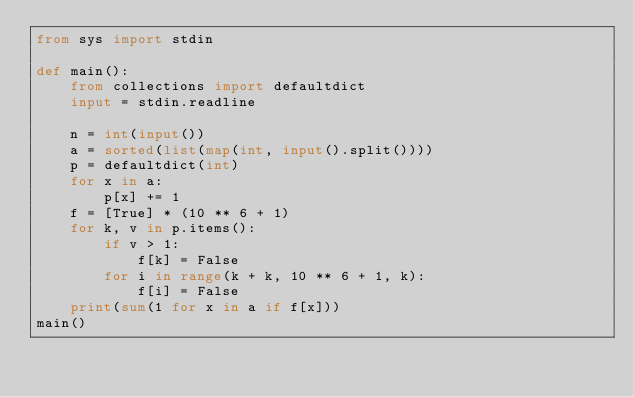Convert code to text. <code><loc_0><loc_0><loc_500><loc_500><_Python_>from sys import stdin

def main():
    from collections import defaultdict
    input = stdin.readline

    n = int(input())
    a = sorted(list(map(int, input().split())))
    p = defaultdict(int)
    for x in a:
        p[x] += 1
    f = [True] * (10 ** 6 + 1)
    for k, v in p.items():
        if v > 1:
            f[k] = False
        for i in range(k + k, 10 ** 6 + 1, k):
            f[i] = False
    print(sum(1 for x in a if f[x]))
main()</code> 